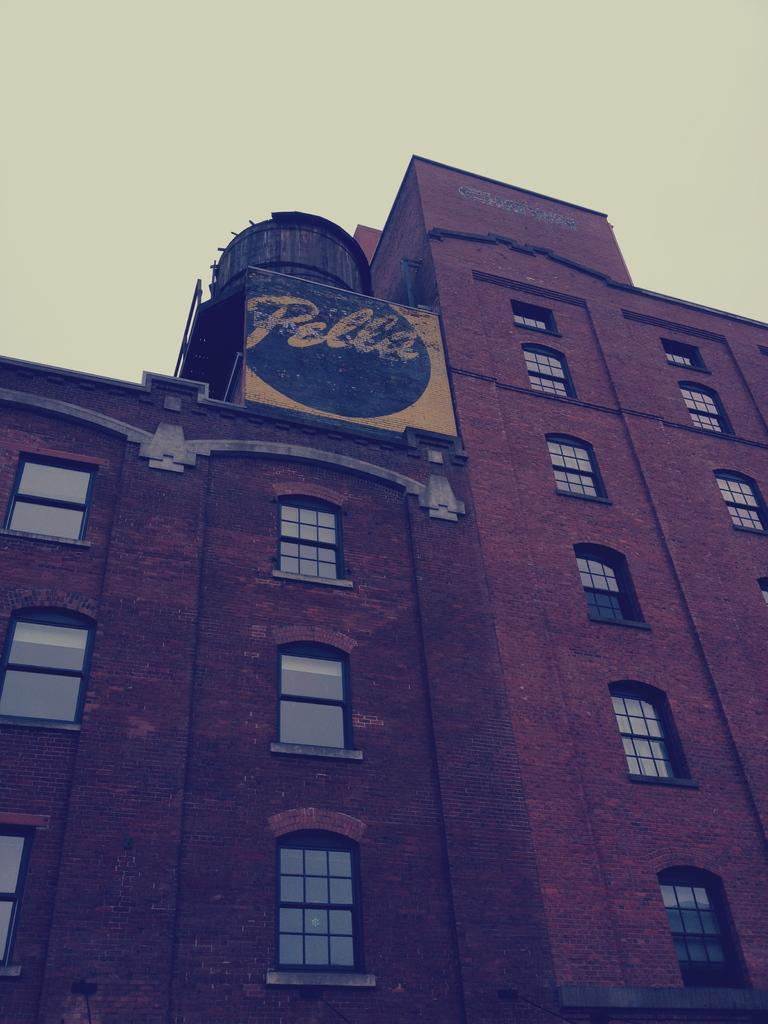How would you summarize this image in a sentence or two? In this picture I can observe brown color building. There are some windows. In the background there is a sky. 